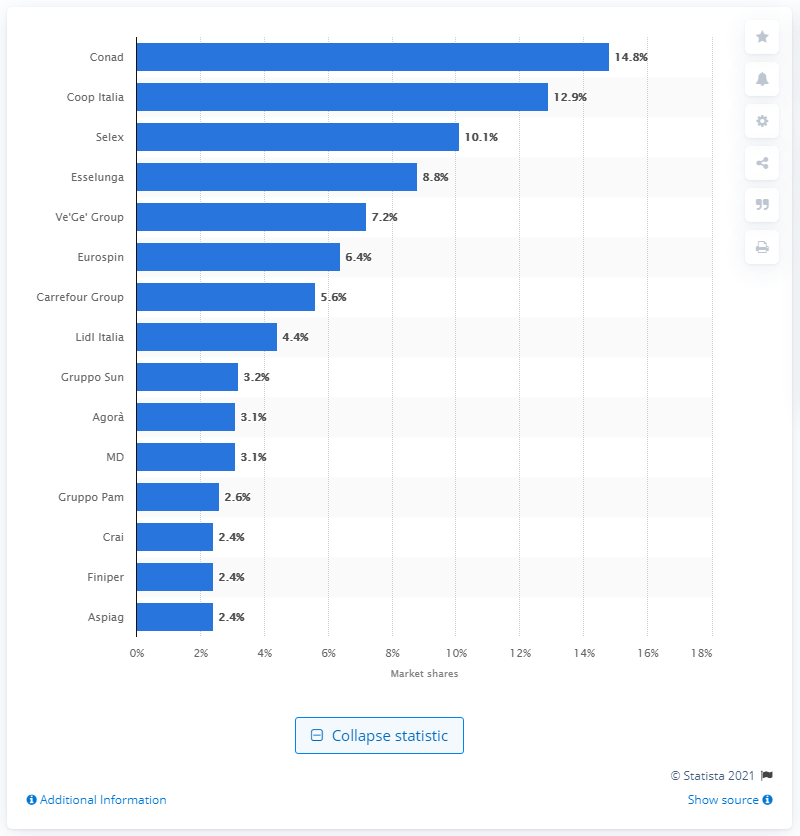List a handful of essential elements in this visual. The market share of Coop Italia was 12.9.. Conad held a market share of 14.8% during the period of consideration. 